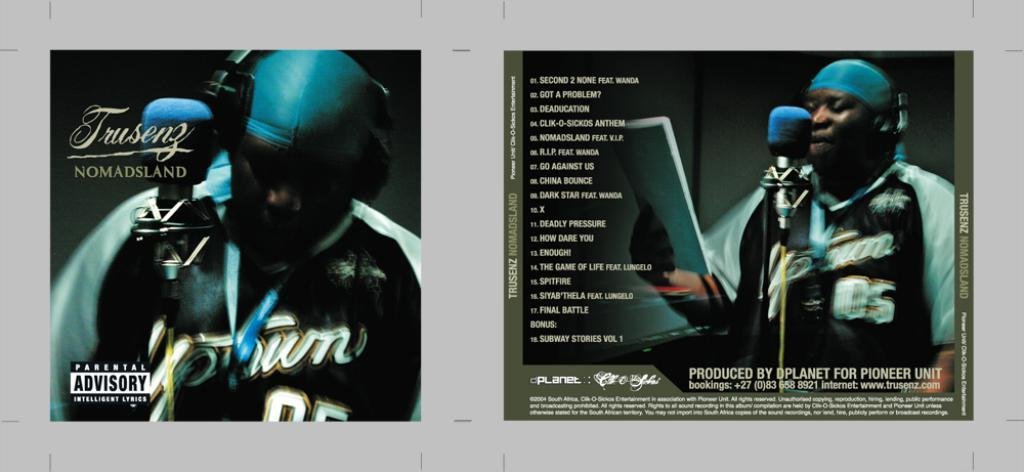<image>
Share a concise interpretation of the image provided. The front cd cover shows a black man standing in front of a microphone and there is a parental advisory warning in the bottom left corner. 